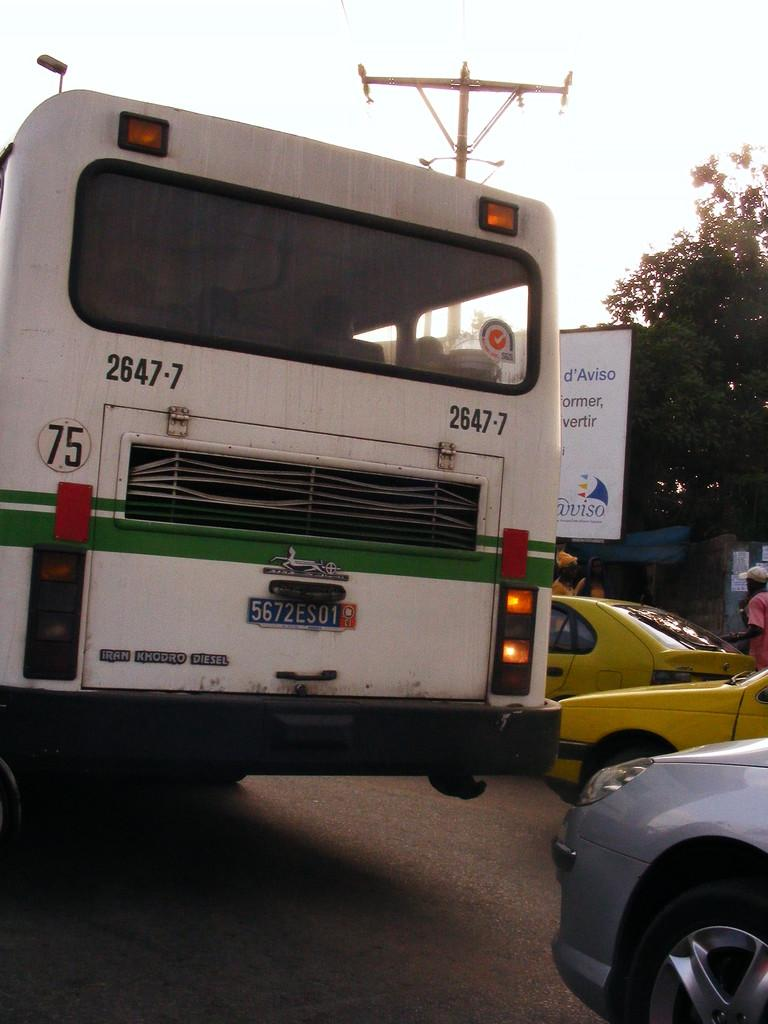<image>
Render a clear and concise summary of the photo. The bus shown has the words Iran KKodro Diesel written on the back. 